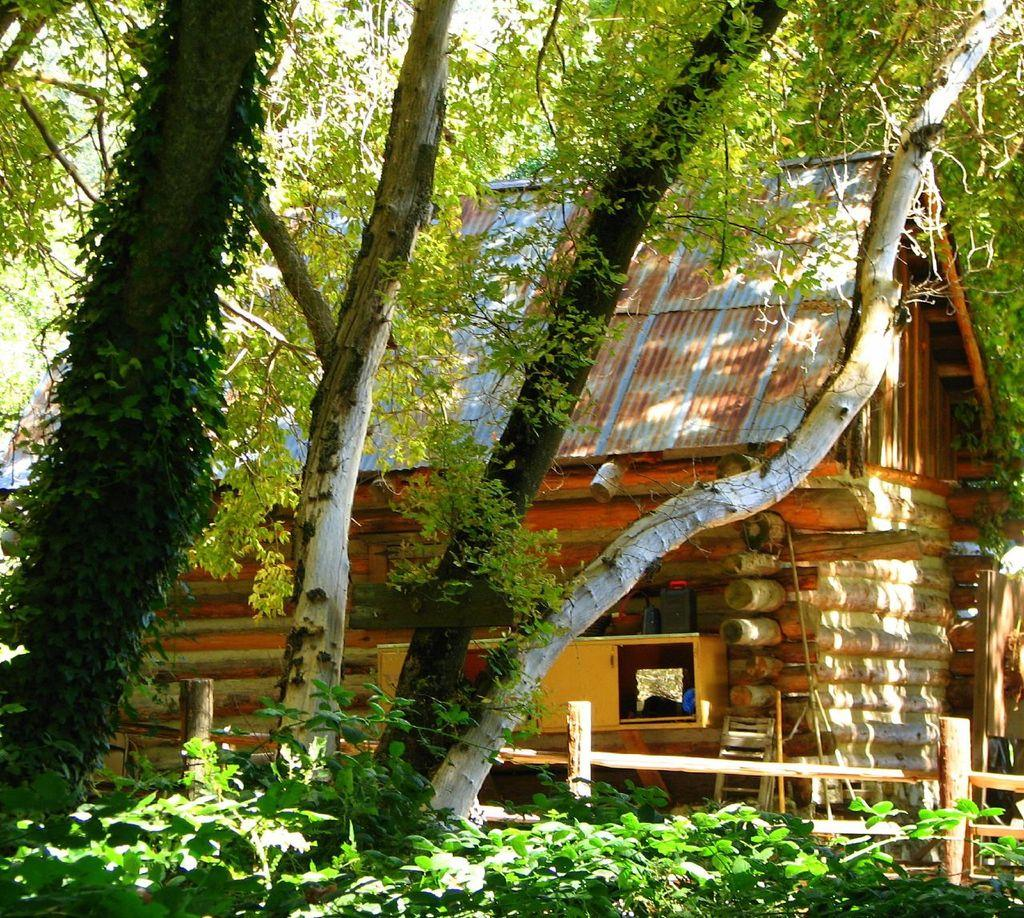What type of vegetation can be seen in the image? There are trees in the image. What structure is located at the center of the image? There is a wooden house at the center of the image. What type of blade can be seen in the image? There is no blade present in the image. Is there a judge visible in the image? There is no judge present in the image. Can you see a boat in the image? There is no boat present in the image. 